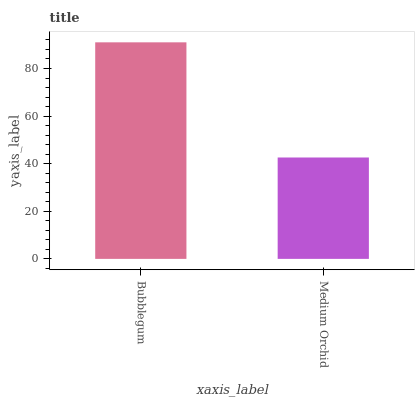Is Medium Orchid the minimum?
Answer yes or no. Yes. Is Bubblegum the maximum?
Answer yes or no. Yes. Is Medium Orchid the maximum?
Answer yes or no. No. Is Bubblegum greater than Medium Orchid?
Answer yes or no. Yes. Is Medium Orchid less than Bubblegum?
Answer yes or no. Yes. Is Medium Orchid greater than Bubblegum?
Answer yes or no. No. Is Bubblegum less than Medium Orchid?
Answer yes or no. No. Is Bubblegum the high median?
Answer yes or no. Yes. Is Medium Orchid the low median?
Answer yes or no. Yes. Is Medium Orchid the high median?
Answer yes or no. No. Is Bubblegum the low median?
Answer yes or no. No. 